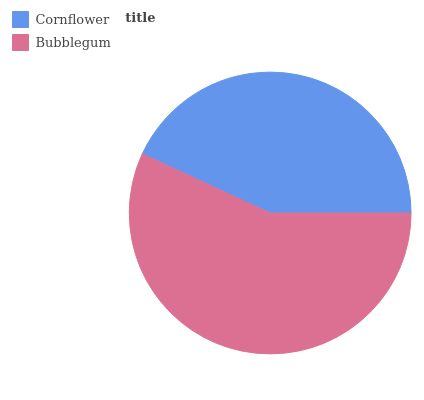Is Cornflower the minimum?
Answer yes or no. Yes. Is Bubblegum the maximum?
Answer yes or no. Yes. Is Bubblegum the minimum?
Answer yes or no. No. Is Bubblegum greater than Cornflower?
Answer yes or no. Yes. Is Cornflower less than Bubblegum?
Answer yes or no. Yes. Is Cornflower greater than Bubblegum?
Answer yes or no. No. Is Bubblegum less than Cornflower?
Answer yes or no. No. Is Bubblegum the high median?
Answer yes or no. Yes. Is Cornflower the low median?
Answer yes or no. Yes. Is Cornflower the high median?
Answer yes or no. No. Is Bubblegum the low median?
Answer yes or no. No. 